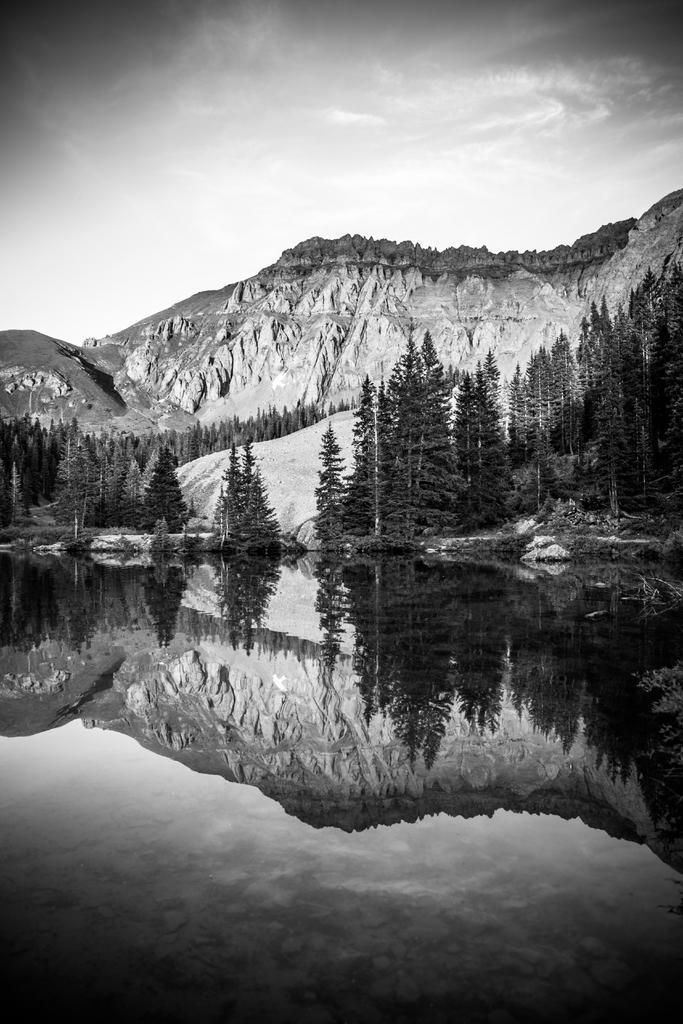Can you describe this image briefly? In this image on the foreground there is water body. On it we can see reflection of mountain, trees. In the background there is mountain and trees. 